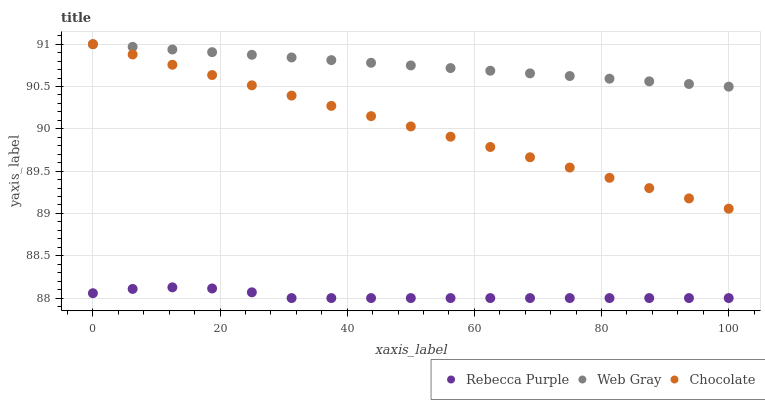Does Rebecca Purple have the minimum area under the curve?
Answer yes or no. Yes. Does Web Gray have the maximum area under the curve?
Answer yes or no. Yes. Does Chocolate have the minimum area under the curve?
Answer yes or no. No. Does Chocolate have the maximum area under the curve?
Answer yes or no. No. Is Web Gray the smoothest?
Answer yes or no. Yes. Is Rebecca Purple the roughest?
Answer yes or no. Yes. Is Chocolate the smoothest?
Answer yes or no. No. Is Chocolate the roughest?
Answer yes or no. No. Does Rebecca Purple have the lowest value?
Answer yes or no. Yes. Does Chocolate have the lowest value?
Answer yes or no. No. Does Chocolate have the highest value?
Answer yes or no. Yes. Does Rebecca Purple have the highest value?
Answer yes or no. No. Is Rebecca Purple less than Chocolate?
Answer yes or no. Yes. Is Web Gray greater than Rebecca Purple?
Answer yes or no. Yes. Does Chocolate intersect Web Gray?
Answer yes or no. Yes. Is Chocolate less than Web Gray?
Answer yes or no. No. Is Chocolate greater than Web Gray?
Answer yes or no. No. Does Rebecca Purple intersect Chocolate?
Answer yes or no. No. 